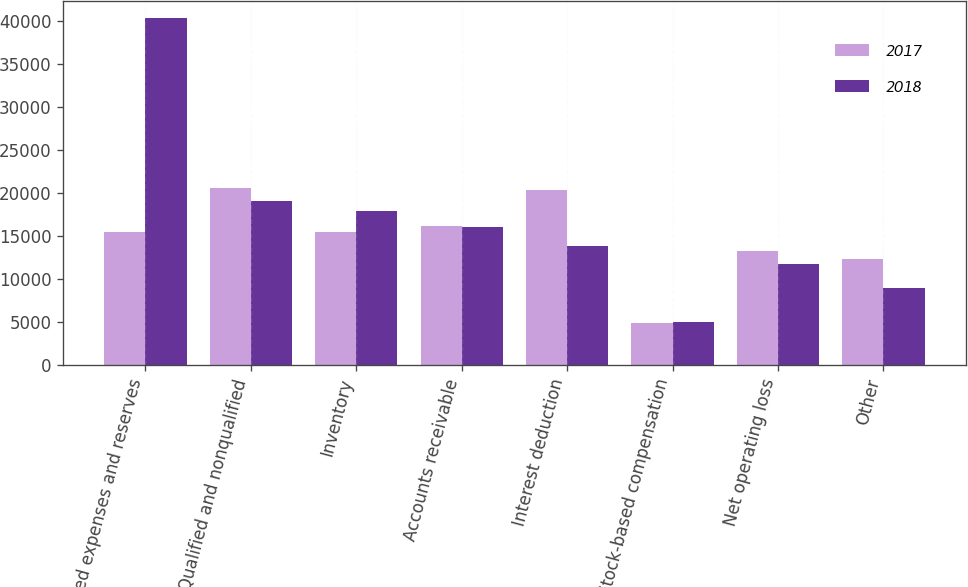<chart> <loc_0><loc_0><loc_500><loc_500><stacked_bar_chart><ecel><fcel>Accrued expenses and reserves<fcel>Qualified and nonqualified<fcel>Inventory<fcel>Accounts receivable<fcel>Interest deduction<fcel>Stock-based compensation<fcel>Net operating loss<fcel>Other<nl><fcel>2017<fcel>15474<fcel>20525<fcel>15474<fcel>16208<fcel>20392<fcel>4859<fcel>13222<fcel>12370<nl><fcel>2018<fcel>40317<fcel>19074<fcel>17886<fcel>16036<fcel>13845<fcel>4963<fcel>11734<fcel>8971<nl></chart> 